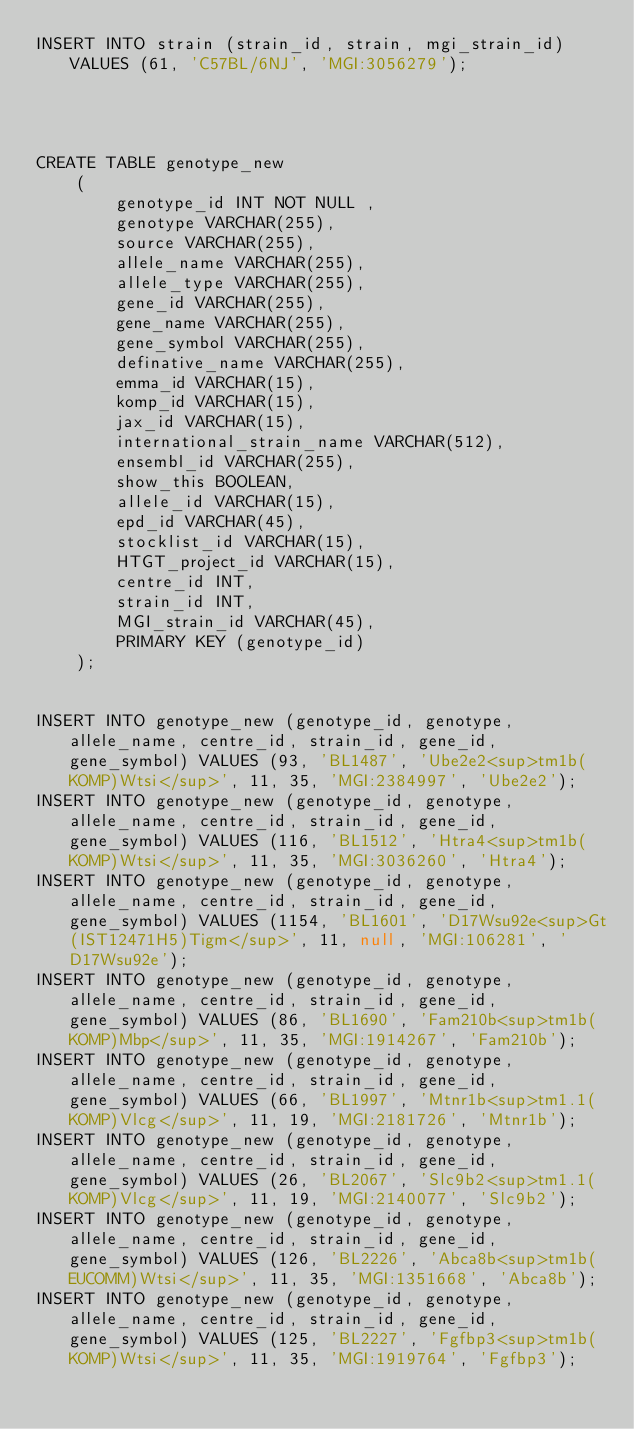<code> <loc_0><loc_0><loc_500><loc_500><_SQL_>INSERT INTO strain (strain_id, strain, mgi_strain_id) VALUES (61, 'C57BL/6NJ', 'MGI:3056279');




CREATE TABLE genotype_new
    (
        genotype_id INT NOT NULL ,
        genotype VARCHAR(255),
        source VARCHAR(255),
        allele_name VARCHAR(255),
        allele_type VARCHAR(255),
        gene_id VARCHAR(255),
        gene_name VARCHAR(255),
        gene_symbol VARCHAR(255),
        definative_name VARCHAR(255),
        emma_id VARCHAR(15),
        komp_id VARCHAR(15),
        jax_id VARCHAR(15),
        international_strain_name VARCHAR(512),
        ensembl_id VARCHAR(255),
        show_this BOOLEAN,
        allele_id VARCHAR(15),
        epd_id VARCHAR(45),
        stocklist_id VARCHAR(15),
        HTGT_project_id VARCHAR(15),
        centre_id INT,
        strain_id INT,
        MGI_strain_id VARCHAR(45),
        PRIMARY KEY (genotype_id)
    );


INSERT INTO genotype_new (genotype_id, genotype, allele_name, centre_id, strain_id, gene_id, gene_symbol) VALUES (93, 'BL1487', 'Ube2e2<sup>tm1b(KOMP)Wtsi</sup>', 11, 35, 'MGI:2384997', 'Ube2e2');
INSERT INTO genotype_new (genotype_id, genotype, allele_name, centre_id, strain_id, gene_id, gene_symbol) VALUES (116, 'BL1512', 'Htra4<sup>tm1b(KOMP)Wtsi</sup>', 11, 35, 'MGI:3036260', 'Htra4');
INSERT INTO genotype_new (genotype_id, genotype, allele_name, centre_id, strain_id, gene_id, gene_symbol) VALUES (1154, 'BL1601', 'D17Wsu92e<sup>Gt(IST12471H5)Tigm</sup>', 11, null, 'MGI:106281', 'D17Wsu92e');
INSERT INTO genotype_new (genotype_id, genotype, allele_name, centre_id, strain_id, gene_id, gene_symbol) VALUES (86, 'BL1690', 'Fam210b<sup>tm1b(KOMP)Mbp</sup>', 11, 35, 'MGI:1914267', 'Fam210b');
INSERT INTO genotype_new (genotype_id, genotype, allele_name, centre_id, strain_id, gene_id, gene_symbol) VALUES (66, 'BL1997', 'Mtnr1b<sup>tm1.1(KOMP)Vlcg</sup>', 11, 19, 'MGI:2181726', 'Mtnr1b');
INSERT INTO genotype_new (genotype_id, genotype, allele_name, centre_id, strain_id, gene_id, gene_symbol) VALUES (26, 'BL2067', 'Slc9b2<sup>tm1.1(KOMP)Vlcg</sup>', 11, 19, 'MGI:2140077', 'Slc9b2');
INSERT INTO genotype_new (genotype_id, genotype, allele_name, centre_id, strain_id, gene_id, gene_symbol) VALUES (126, 'BL2226', 'Abca8b<sup>tm1b(EUCOMM)Wtsi</sup>', 11, 35, 'MGI:1351668', 'Abca8b');
INSERT INTO genotype_new (genotype_id, genotype, allele_name, centre_id, strain_id, gene_id, gene_symbol) VALUES (125, 'BL2227', 'Fgfbp3<sup>tm1b(KOMP)Wtsi</sup>', 11, 35, 'MGI:1919764', 'Fgfbp3');</code> 